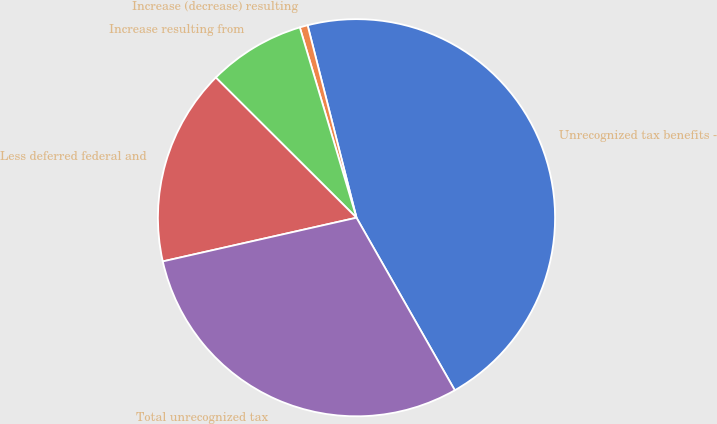Convert chart. <chart><loc_0><loc_0><loc_500><loc_500><pie_chart><fcel>Unrecognized tax benefits -<fcel>Increase (decrease) resulting<fcel>Increase resulting from<fcel>Less deferred federal and<fcel>Total unrecognized tax<nl><fcel>45.71%<fcel>0.65%<fcel>7.92%<fcel>16.0%<fcel>29.71%<nl></chart> 